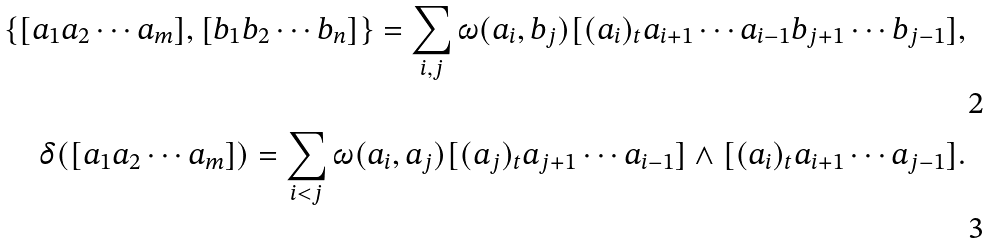<formula> <loc_0><loc_0><loc_500><loc_500>\{ [ a _ { 1 } a _ { 2 } \cdots a _ { m } ] , [ b _ { 1 } b _ { 2 } \cdots b _ { n } ] \} = \sum _ { i , j } \omega ( a _ { i } , b _ { j } ) [ ( a _ { i } ) _ { t } a _ { i + 1 } \cdots a _ { i - 1 } b _ { j + 1 } \cdots b _ { j - 1 } ] , \\ \delta ( [ a _ { 1 } a _ { 2 } \cdots a _ { m } ] ) = \sum _ { i < j } \omega ( a _ { i } , a _ { j } ) [ ( a _ { j } ) _ { t } a _ { j + 1 } \cdots a _ { i - 1 } ] \wedge [ ( a _ { i } ) _ { t } a _ { i + 1 } \cdots a _ { j - 1 } ] .</formula> 